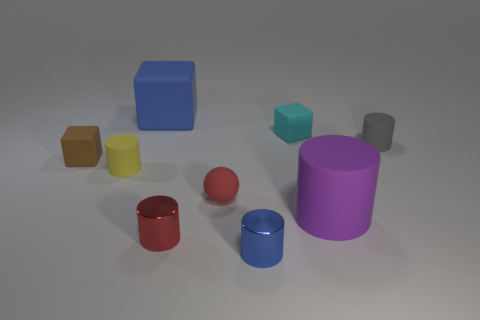There is a tiny thing that is the same color as the tiny ball; what shape is it?
Your answer should be very brief. Cylinder. Does the big rubber object that is right of the red matte thing have the same shape as the small blue object?
Your response must be concise. Yes. There is a small cylinder that is the same material as the tiny blue thing; what color is it?
Provide a succinct answer. Red. Is there a rubber block on the left side of the large object that is to the left of the cyan cube that is behind the red matte sphere?
Offer a very short reply. Yes. There is a small yellow thing; what shape is it?
Give a very brief answer. Cylinder. Is the number of large blue blocks on the right side of the cyan block less than the number of cyan rubber blocks?
Your answer should be compact. Yes. Is there a cyan matte object of the same shape as the small brown rubber object?
Ensure brevity in your answer.  Yes. There is a blue metallic thing that is the same size as the gray thing; what is its shape?
Your response must be concise. Cylinder. What number of things are either small matte cylinders or blue metal things?
Offer a very short reply. 3. Are there any cyan matte blocks?
Make the answer very short. Yes. 